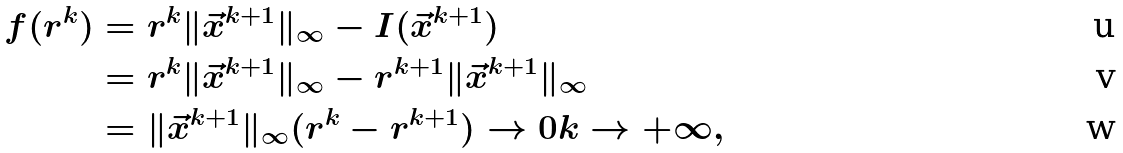<formula> <loc_0><loc_0><loc_500><loc_500>f ( r ^ { k } ) & = r ^ { k } \| \vec { x } ^ { k + 1 } \| _ { \infty } - I ( \vec { x } ^ { k + 1 } ) \\ & = r ^ { k } \| \vec { x } ^ { k + 1 } \| _ { \infty } - r ^ { k + 1 } \| \vec { x } ^ { k + 1 } \| _ { \infty } \\ & = \| \vec { x } ^ { k + 1 } \| _ { \infty } ( r ^ { k } - r ^ { k + 1 } ) \to 0 k \to + \infty ,</formula> 